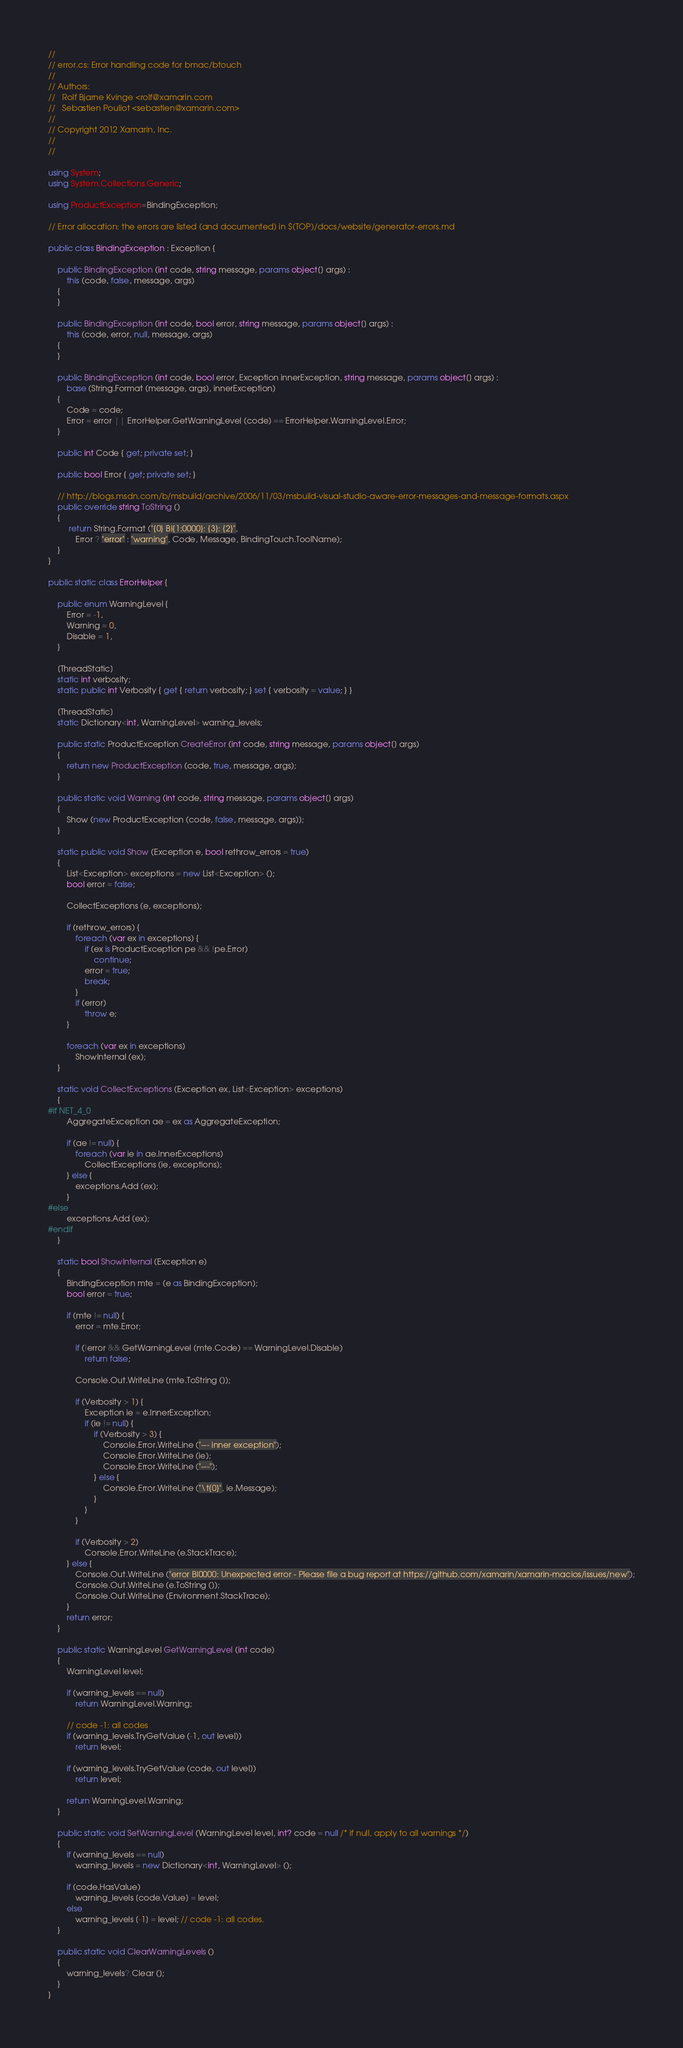<code> <loc_0><loc_0><loc_500><loc_500><_C#_>//
// error.cs: Error handling code for bmac/btouch
//
// Authors:
//   Rolf Bjarne Kvinge <rolf@xamarin.com
//   Sebastien Pouliot <sebastien@xamarin.com>
//
// Copyright 2012 Xamarin, Inc.
//
//

using System;
using System.Collections.Generic;

using ProductException=BindingException;

// Error allocation: the errors are listed (and documented) in $(TOP)/docs/website/generator-errors.md

public class BindingException : Exception {
	
	public BindingException (int code, string message, params object[] args) : 
		this (code, false, message, args)
	{
	}

	public BindingException (int code, bool error, string message, params object[] args) : 
		this (code, error, null, message, args)
	{
	}

	public BindingException (int code, bool error, Exception innerException, string message, params object[] args) : 
		base (String.Format (message, args), innerException)
	{
		Code = code;
		Error = error || ErrorHelper.GetWarningLevel (code) == ErrorHelper.WarningLevel.Error;
	}

	public int Code { get; private set; }
	
	public bool Error { get; private set; }
	
	// http://blogs.msdn.com/b/msbuild/archive/2006/11/03/msbuild-visual-studio-aware-error-messages-and-message-formats.aspx
	public override string ToString ()
	{
		 return String.Format ("{0} BI{1:0000}: {3}: {2}",
			Error ? "error" : "warning", Code, Message, BindingTouch.ToolName);
	}
}

public static class ErrorHelper {

	public enum WarningLevel {
		Error = -1,
		Warning = 0,
		Disable = 1,
	}

	[ThreadStatic]
	static int verbosity;
	static public int Verbosity { get { return verbosity; } set { verbosity = value; } }

	[ThreadStatic]
	static Dictionary<int, WarningLevel> warning_levels;
	
	public static ProductException CreateError (int code, string message, params object[] args)
	{
		return new ProductException (code, true, message, args);
	}

	public static void Warning (int code, string message, params object[] args)
	{
		Show (new ProductException (code, false, message, args));
	}

	static public void Show (Exception e, bool rethrow_errors = true)
	{
		List<Exception> exceptions = new List<Exception> ();
		bool error = false;

		CollectExceptions (e, exceptions);

		if (rethrow_errors) {
			foreach (var ex in exceptions) {
				if (ex is ProductException pe && !pe.Error)
					continue;
				error = true;
				break;
			}
			if (error)
				throw e;
		}

		foreach (var ex in exceptions)
			ShowInternal (ex);
	}

	static void CollectExceptions (Exception ex, List<Exception> exceptions)
	{
#if NET_4_0
		AggregateException ae = ex as AggregateException;

		if (ae != null) {
			foreach (var ie in ae.InnerExceptions)
				CollectExceptions (ie, exceptions);
		} else {
			exceptions.Add (ex);
		}
#else
		exceptions.Add (ex);
#endif
	}

	static bool ShowInternal (Exception e)
	{
		BindingException mte = (e as BindingException);
		bool error = true;

		if (mte != null) {
			error = mte.Error;

			if (!error && GetWarningLevel (mte.Code) == WarningLevel.Disable)
				return false;

			Console.Out.WriteLine (mte.ToString ());
			
			if (Verbosity > 1) {
				Exception ie = e.InnerException;
				if (ie != null) {
					if (Verbosity > 3) {
						Console.Error.WriteLine ("--- inner exception");
						Console.Error.WriteLine (ie);
						Console.Error.WriteLine ("---");
					} else {
						Console.Error.WriteLine ("\t{0}", ie.Message);
					}
				}
			}
			
			if (Verbosity > 2)
				Console.Error.WriteLine (e.StackTrace);
		} else {
			Console.Out.WriteLine ("error BI0000: Unexpected error - Please file a bug report at https://github.com/xamarin/xamarin-macios/issues/new");
			Console.Out.WriteLine (e.ToString ());
			Console.Out.WriteLine (Environment.StackTrace);
		}
		return error;
	}

	public static WarningLevel GetWarningLevel (int code)
	{
		WarningLevel level;

		if (warning_levels == null)
			return WarningLevel.Warning;

		// code -1: all codes
		if (warning_levels.TryGetValue (-1, out level))
			return level;

		if (warning_levels.TryGetValue (code, out level))
			return level;

		return WarningLevel.Warning;
	}

	public static void SetWarningLevel (WarningLevel level, int? code = null /* if null, apply to all warnings */)
	{
		if (warning_levels == null)
			warning_levels = new Dictionary<int, WarningLevel> ();

		if (code.HasValue)
			warning_levels [code.Value] = level;
		else
			warning_levels [-1] = level; // code -1: all codes.
	}

	public static void ClearWarningLevels ()
	{
		warning_levels?.Clear ();
	}
}
</code> 